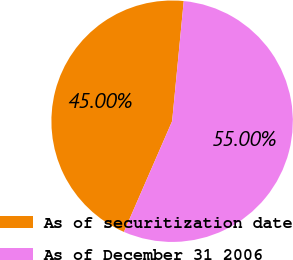<chart> <loc_0><loc_0><loc_500><loc_500><pie_chart><fcel>As of securitization date<fcel>As of December 31 2006<nl><fcel>45.0%<fcel>55.0%<nl></chart> 